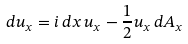Convert formula to latex. <formula><loc_0><loc_0><loc_500><loc_500>d u _ { x } = i \, d x \, u _ { x } - \frac { 1 } { 2 } u _ { x } \, d A _ { x }</formula> 